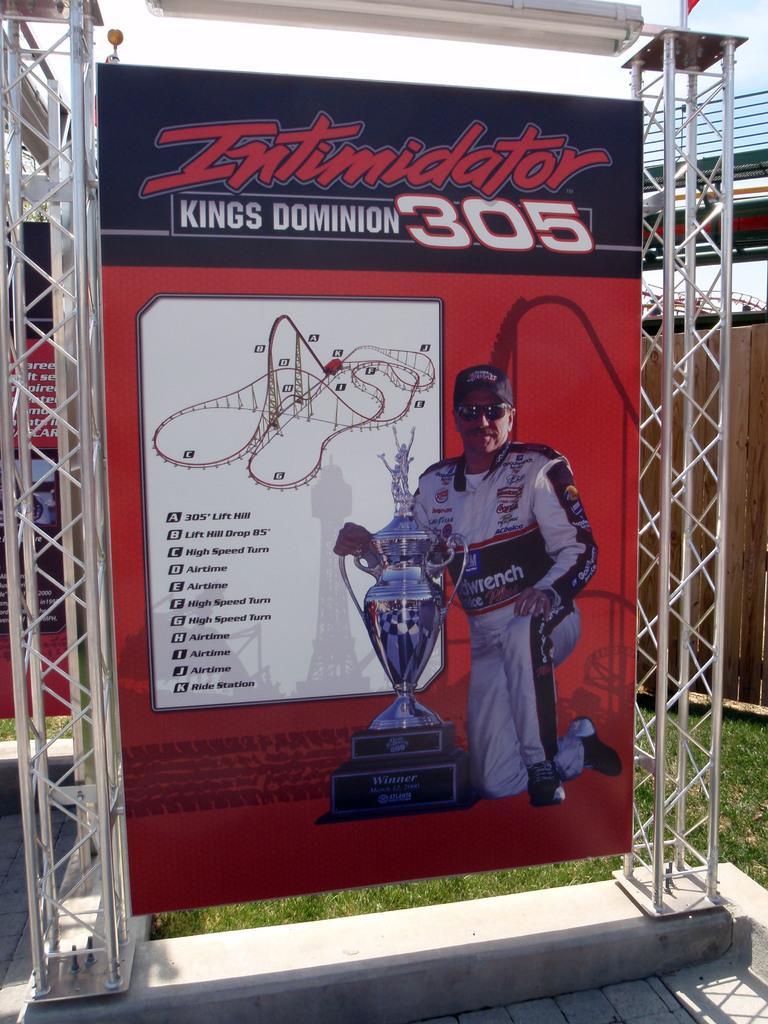<image>
Relay a brief, clear account of the picture shown. a man is standing with a trophy in front of an Intimidator 305 sign 